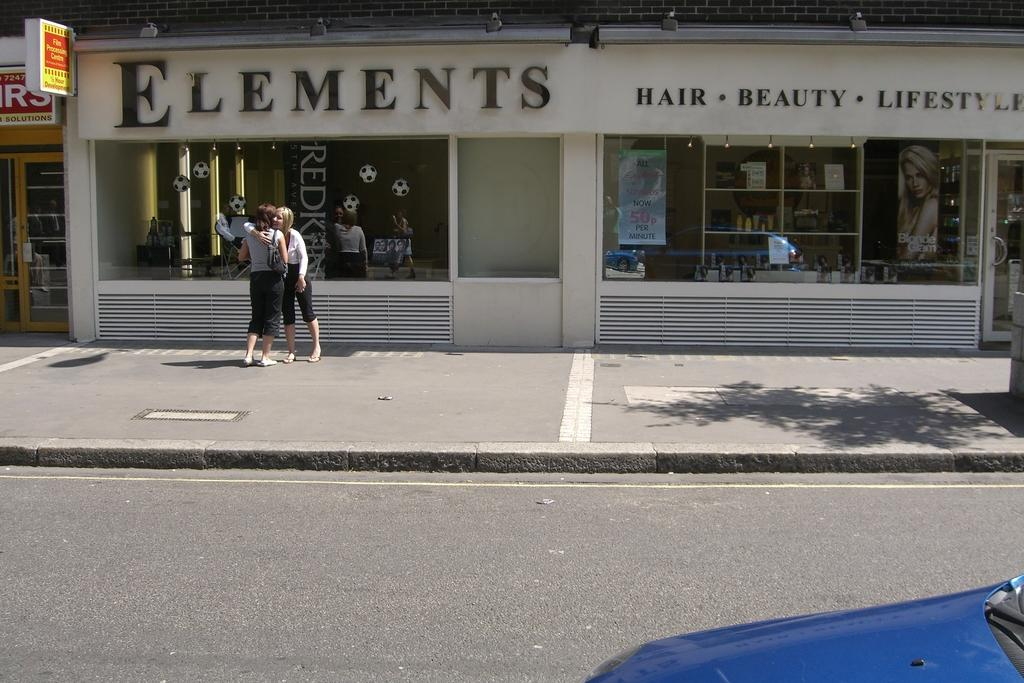Provide a one-sentence caption for the provided image. Two women stand in front of Elements hair, beauty, and lifestyle salon. 